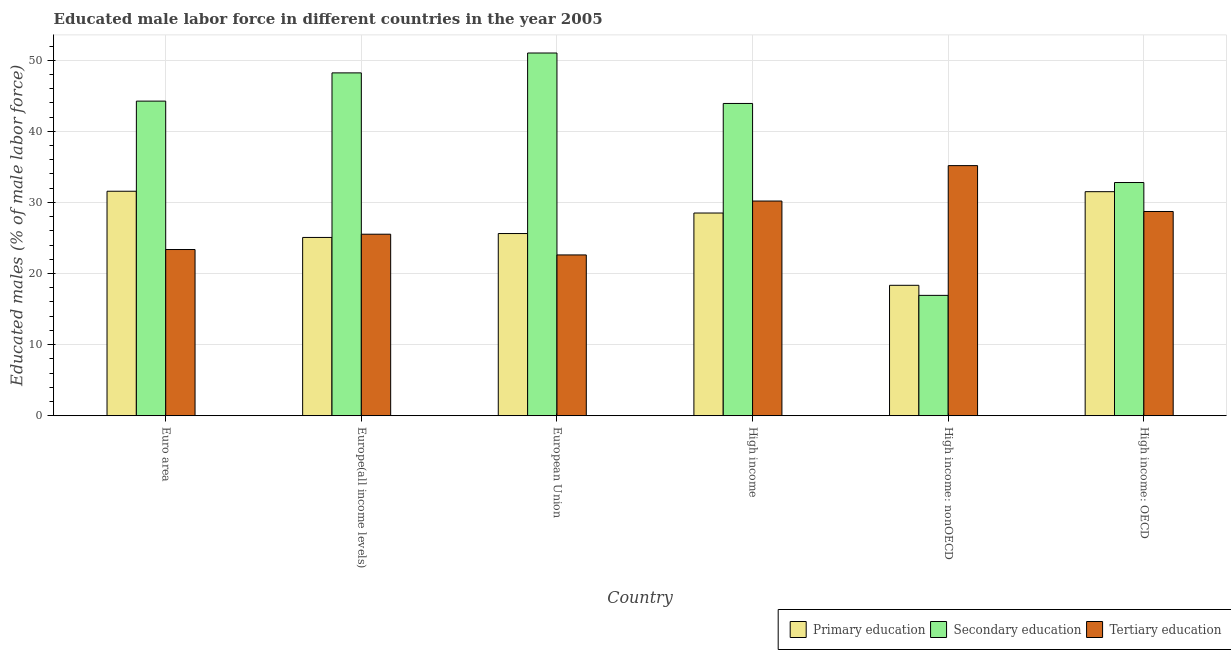How many groups of bars are there?
Your answer should be compact. 6. What is the percentage of male labor force who received primary education in High income: nonOECD?
Provide a short and direct response. 18.34. Across all countries, what is the maximum percentage of male labor force who received primary education?
Provide a succinct answer. 31.57. Across all countries, what is the minimum percentage of male labor force who received tertiary education?
Offer a very short reply. 22.62. In which country was the percentage of male labor force who received secondary education maximum?
Ensure brevity in your answer.  European Union. In which country was the percentage of male labor force who received secondary education minimum?
Your answer should be compact. High income: nonOECD. What is the total percentage of male labor force who received tertiary education in the graph?
Provide a short and direct response. 165.62. What is the difference between the percentage of male labor force who received primary education in Euro area and that in High income: nonOECD?
Keep it short and to the point. 13.23. What is the difference between the percentage of male labor force who received tertiary education in Euro area and the percentage of male labor force who received secondary education in High income: nonOECD?
Offer a very short reply. 6.45. What is the average percentage of male labor force who received tertiary education per country?
Provide a short and direct response. 27.6. What is the difference between the percentage of male labor force who received tertiary education and percentage of male labor force who received primary education in European Union?
Provide a succinct answer. -3.01. In how many countries, is the percentage of male labor force who received tertiary education greater than 24 %?
Your answer should be compact. 4. What is the ratio of the percentage of male labor force who received secondary education in European Union to that in High income: OECD?
Your answer should be compact. 1.56. Is the percentage of male labor force who received secondary education in Euro area less than that in High income: OECD?
Your answer should be compact. No. What is the difference between the highest and the second highest percentage of male labor force who received primary education?
Offer a very short reply. 0.06. What is the difference between the highest and the lowest percentage of male labor force who received secondary education?
Make the answer very short. 34.09. Is the sum of the percentage of male labor force who received secondary education in European Union and High income greater than the maximum percentage of male labor force who received tertiary education across all countries?
Your answer should be compact. Yes. What does the 1st bar from the left in Euro area represents?
Your answer should be compact. Primary education. What does the 1st bar from the right in High income represents?
Your response must be concise. Tertiary education. How many bars are there?
Provide a succinct answer. 18. Are all the bars in the graph horizontal?
Your response must be concise. No. How many countries are there in the graph?
Give a very brief answer. 6. Are the values on the major ticks of Y-axis written in scientific E-notation?
Ensure brevity in your answer.  No. Does the graph contain grids?
Your answer should be very brief. Yes. Where does the legend appear in the graph?
Offer a very short reply. Bottom right. How many legend labels are there?
Provide a succinct answer. 3. What is the title of the graph?
Give a very brief answer. Educated male labor force in different countries in the year 2005. Does "Refusal of sex" appear as one of the legend labels in the graph?
Your answer should be compact. No. What is the label or title of the X-axis?
Ensure brevity in your answer.  Country. What is the label or title of the Y-axis?
Give a very brief answer. Educated males (% of male labor force). What is the Educated males (% of male labor force) of Primary education in Euro area?
Your answer should be very brief. 31.57. What is the Educated males (% of male labor force) of Secondary education in Euro area?
Provide a short and direct response. 44.25. What is the Educated males (% of male labor force) of Tertiary education in Euro area?
Your answer should be very brief. 23.38. What is the Educated males (% of male labor force) of Primary education in Europe(all income levels)?
Give a very brief answer. 25.07. What is the Educated males (% of male labor force) in Secondary education in Europe(all income levels)?
Offer a terse response. 48.22. What is the Educated males (% of male labor force) of Tertiary education in Europe(all income levels)?
Your answer should be very brief. 25.53. What is the Educated males (% of male labor force) in Primary education in European Union?
Your response must be concise. 25.62. What is the Educated males (% of male labor force) in Secondary education in European Union?
Your answer should be compact. 51.01. What is the Educated males (% of male labor force) in Tertiary education in European Union?
Make the answer very short. 22.62. What is the Educated males (% of male labor force) in Primary education in High income?
Offer a very short reply. 28.51. What is the Educated males (% of male labor force) in Secondary education in High income?
Offer a terse response. 43.92. What is the Educated males (% of male labor force) of Tertiary education in High income?
Ensure brevity in your answer.  30.2. What is the Educated males (% of male labor force) in Primary education in High income: nonOECD?
Ensure brevity in your answer.  18.34. What is the Educated males (% of male labor force) of Secondary education in High income: nonOECD?
Your answer should be very brief. 16.93. What is the Educated males (% of male labor force) of Tertiary education in High income: nonOECD?
Provide a short and direct response. 35.18. What is the Educated males (% of male labor force) in Primary education in High income: OECD?
Give a very brief answer. 31.51. What is the Educated males (% of male labor force) in Secondary education in High income: OECD?
Provide a short and direct response. 32.8. What is the Educated males (% of male labor force) of Tertiary education in High income: OECD?
Keep it short and to the point. 28.72. Across all countries, what is the maximum Educated males (% of male labor force) of Primary education?
Ensure brevity in your answer.  31.57. Across all countries, what is the maximum Educated males (% of male labor force) in Secondary education?
Ensure brevity in your answer.  51.01. Across all countries, what is the maximum Educated males (% of male labor force) of Tertiary education?
Offer a terse response. 35.18. Across all countries, what is the minimum Educated males (% of male labor force) in Primary education?
Your answer should be very brief. 18.34. Across all countries, what is the minimum Educated males (% of male labor force) in Secondary education?
Offer a terse response. 16.93. Across all countries, what is the minimum Educated males (% of male labor force) in Tertiary education?
Provide a short and direct response. 22.62. What is the total Educated males (% of male labor force) of Primary education in the graph?
Provide a short and direct response. 160.63. What is the total Educated males (% of male labor force) in Secondary education in the graph?
Provide a succinct answer. 237.13. What is the total Educated males (% of male labor force) of Tertiary education in the graph?
Offer a terse response. 165.62. What is the difference between the Educated males (% of male labor force) in Primary education in Euro area and that in Europe(all income levels)?
Provide a succinct answer. 6.5. What is the difference between the Educated males (% of male labor force) in Secondary education in Euro area and that in Europe(all income levels)?
Offer a terse response. -3.97. What is the difference between the Educated males (% of male labor force) in Tertiary education in Euro area and that in Europe(all income levels)?
Offer a terse response. -2.15. What is the difference between the Educated males (% of male labor force) of Primary education in Euro area and that in European Union?
Ensure brevity in your answer.  5.95. What is the difference between the Educated males (% of male labor force) of Secondary education in Euro area and that in European Union?
Offer a terse response. -6.77. What is the difference between the Educated males (% of male labor force) of Tertiary education in Euro area and that in European Union?
Ensure brevity in your answer.  0.76. What is the difference between the Educated males (% of male labor force) of Primary education in Euro area and that in High income?
Your answer should be compact. 3.06. What is the difference between the Educated males (% of male labor force) of Secondary education in Euro area and that in High income?
Your answer should be compact. 0.33. What is the difference between the Educated males (% of male labor force) of Tertiary education in Euro area and that in High income?
Your response must be concise. -6.82. What is the difference between the Educated males (% of male labor force) of Primary education in Euro area and that in High income: nonOECD?
Make the answer very short. 13.23. What is the difference between the Educated males (% of male labor force) in Secondary education in Euro area and that in High income: nonOECD?
Give a very brief answer. 27.32. What is the difference between the Educated males (% of male labor force) in Tertiary education in Euro area and that in High income: nonOECD?
Provide a succinct answer. -11.8. What is the difference between the Educated males (% of male labor force) in Primary education in Euro area and that in High income: OECD?
Your answer should be very brief. 0.06. What is the difference between the Educated males (% of male labor force) in Secondary education in Euro area and that in High income: OECD?
Your answer should be very brief. 11.45. What is the difference between the Educated males (% of male labor force) in Tertiary education in Euro area and that in High income: OECD?
Provide a short and direct response. -5.35. What is the difference between the Educated males (% of male labor force) in Primary education in Europe(all income levels) and that in European Union?
Give a very brief answer. -0.55. What is the difference between the Educated males (% of male labor force) of Secondary education in Europe(all income levels) and that in European Union?
Your answer should be very brief. -2.8. What is the difference between the Educated males (% of male labor force) in Tertiary education in Europe(all income levels) and that in European Union?
Your answer should be compact. 2.91. What is the difference between the Educated males (% of male labor force) of Primary education in Europe(all income levels) and that in High income?
Your answer should be very brief. -3.43. What is the difference between the Educated males (% of male labor force) in Secondary education in Europe(all income levels) and that in High income?
Offer a terse response. 4.3. What is the difference between the Educated males (% of male labor force) of Tertiary education in Europe(all income levels) and that in High income?
Give a very brief answer. -4.67. What is the difference between the Educated males (% of male labor force) in Primary education in Europe(all income levels) and that in High income: nonOECD?
Make the answer very short. 6.73. What is the difference between the Educated males (% of male labor force) of Secondary education in Europe(all income levels) and that in High income: nonOECD?
Provide a succinct answer. 31.29. What is the difference between the Educated males (% of male labor force) of Tertiary education in Europe(all income levels) and that in High income: nonOECD?
Ensure brevity in your answer.  -9.65. What is the difference between the Educated males (% of male labor force) in Primary education in Europe(all income levels) and that in High income: OECD?
Your response must be concise. -6.44. What is the difference between the Educated males (% of male labor force) of Secondary education in Europe(all income levels) and that in High income: OECD?
Ensure brevity in your answer.  15.42. What is the difference between the Educated males (% of male labor force) of Tertiary education in Europe(all income levels) and that in High income: OECD?
Offer a very short reply. -3.19. What is the difference between the Educated males (% of male labor force) of Primary education in European Union and that in High income?
Your answer should be compact. -2.89. What is the difference between the Educated males (% of male labor force) of Secondary education in European Union and that in High income?
Provide a short and direct response. 7.09. What is the difference between the Educated males (% of male labor force) in Tertiary education in European Union and that in High income?
Give a very brief answer. -7.58. What is the difference between the Educated males (% of male labor force) in Primary education in European Union and that in High income: nonOECD?
Provide a short and direct response. 7.28. What is the difference between the Educated males (% of male labor force) in Secondary education in European Union and that in High income: nonOECD?
Provide a succinct answer. 34.09. What is the difference between the Educated males (% of male labor force) of Tertiary education in European Union and that in High income: nonOECD?
Your answer should be very brief. -12.56. What is the difference between the Educated males (% of male labor force) of Primary education in European Union and that in High income: OECD?
Keep it short and to the point. -5.89. What is the difference between the Educated males (% of male labor force) in Secondary education in European Union and that in High income: OECD?
Your response must be concise. 18.21. What is the difference between the Educated males (% of male labor force) in Tertiary education in European Union and that in High income: OECD?
Keep it short and to the point. -6.11. What is the difference between the Educated males (% of male labor force) in Primary education in High income and that in High income: nonOECD?
Offer a terse response. 10.17. What is the difference between the Educated males (% of male labor force) of Secondary education in High income and that in High income: nonOECD?
Make the answer very short. 26.99. What is the difference between the Educated males (% of male labor force) in Tertiary education in High income and that in High income: nonOECD?
Offer a terse response. -4.98. What is the difference between the Educated males (% of male labor force) of Primary education in High income and that in High income: OECD?
Offer a terse response. -3. What is the difference between the Educated males (% of male labor force) in Secondary education in High income and that in High income: OECD?
Offer a very short reply. 11.12. What is the difference between the Educated males (% of male labor force) of Tertiary education in High income and that in High income: OECD?
Your response must be concise. 1.47. What is the difference between the Educated males (% of male labor force) of Primary education in High income: nonOECD and that in High income: OECD?
Offer a terse response. -13.17. What is the difference between the Educated males (% of male labor force) in Secondary education in High income: nonOECD and that in High income: OECD?
Provide a short and direct response. -15.87. What is the difference between the Educated males (% of male labor force) of Tertiary education in High income: nonOECD and that in High income: OECD?
Provide a short and direct response. 6.45. What is the difference between the Educated males (% of male labor force) of Primary education in Euro area and the Educated males (% of male labor force) of Secondary education in Europe(all income levels)?
Offer a terse response. -16.65. What is the difference between the Educated males (% of male labor force) in Primary education in Euro area and the Educated males (% of male labor force) in Tertiary education in Europe(all income levels)?
Give a very brief answer. 6.04. What is the difference between the Educated males (% of male labor force) of Secondary education in Euro area and the Educated males (% of male labor force) of Tertiary education in Europe(all income levels)?
Ensure brevity in your answer.  18.72. What is the difference between the Educated males (% of male labor force) in Primary education in Euro area and the Educated males (% of male labor force) in Secondary education in European Union?
Keep it short and to the point. -19.44. What is the difference between the Educated males (% of male labor force) of Primary education in Euro area and the Educated males (% of male labor force) of Tertiary education in European Union?
Your response must be concise. 8.96. What is the difference between the Educated males (% of male labor force) in Secondary education in Euro area and the Educated males (% of male labor force) in Tertiary education in European Union?
Give a very brief answer. 21.63. What is the difference between the Educated males (% of male labor force) of Primary education in Euro area and the Educated males (% of male labor force) of Secondary education in High income?
Ensure brevity in your answer.  -12.35. What is the difference between the Educated males (% of male labor force) of Primary education in Euro area and the Educated males (% of male labor force) of Tertiary education in High income?
Keep it short and to the point. 1.38. What is the difference between the Educated males (% of male labor force) of Secondary education in Euro area and the Educated males (% of male labor force) of Tertiary education in High income?
Offer a terse response. 14.05. What is the difference between the Educated males (% of male labor force) of Primary education in Euro area and the Educated males (% of male labor force) of Secondary education in High income: nonOECD?
Offer a very short reply. 14.64. What is the difference between the Educated males (% of male labor force) in Primary education in Euro area and the Educated males (% of male labor force) in Tertiary education in High income: nonOECD?
Your answer should be compact. -3.6. What is the difference between the Educated males (% of male labor force) of Secondary education in Euro area and the Educated males (% of male labor force) of Tertiary education in High income: nonOECD?
Give a very brief answer. 9.07. What is the difference between the Educated males (% of male labor force) in Primary education in Euro area and the Educated males (% of male labor force) in Secondary education in High income: OECD?
Offer a very short reply. -1.23. What is the difference between the Educated males (% of male labor force) of Primary education in Euro area and the Educated males (% of male labor force) of Tertiary education in High income: OECD?
Make the answer very short. 2.85. What is the difference between the Educated males (% of male labor force) in Secondary education in Euro area and the Educated males (% of male labor force) in Tertiary education in High income: OECD?
Provide a short and direct response. 15.52. What is the difference between the Educated males (% of male labor force) in Primary education in Europe(all income levels) and the Educated males (% of male labor force) in Secondary education in European Union?
Your answer should be very brief. -25.94. What is the difference between the Educated males (% of male labor force) of Primary education in Europe(all income levels) and the Educated males (% of male labor force) of Tertiary education in European Union?
Your answer should be compact. 2.46. What is the difference between the Educated males (% of male labor force) of Secondary education in Europe(all income levels) and the Educated males (% of male labor force) of Tertiary education in European Union?
Your answer should be very brief. 25.6. What is the difference between the Educated males (% of male labor force) in Primary education in Europe(all income levels) and the Educated males (% of male labor force) in Secondary education in High income?
Provide a short and direct response. -18.84. What is the difference between the Educated males (% of male labor force) of Primary education in Europe(all income levels) and the Educated males (% of male labor force) of Tertiary education in High income?
Offer a terse response. -5.12. What is the difference between the Educated males (% of male labor force) in Secondary education in Europe(all income levels) and the Educated males (% of male labor force) in Tertiary education in High income?
Your response must be concise. 18.02. What is the difference between the Educated males (% of male labor force) of Primary education in Europe(all income levels) and the Educated males (% of male labor force) of Secondary education in High income: nonOECD?
Provide a short and direct response. 8.15. What is the difference between the Educated males (% of male labor force) in Primary education in Europe(all income levels) and the Educated males (% of male labor force) in Tertiary education in High income: nonOECD?
Keep it short and to the point. -10.1. What is the difference between the Educated males (% of male labor force) of Secondary education in Europe(all income levels) and the Educated males (% of male labor force) of Tertiary education in High income: nonOECD?
Your answer should be compact. 13.04. What is the difference between the Educated males (% of male labor force) in Primary education in Europe(all income levels) and the Educated males (% of male labor force) in Secondary education in High income: OECD?
Your answer should be very brief. -7.73. What is the difference between the Educated males (% of male labor force) of Primary education in Europe(all income levels) and the Educated males (% of male labor force) of Tertiary education in High income: OECD?
Make the answer very short. -3.65. What is the difference between the Educated males (% of male labor force) of Secondary education in Europe(all income levels) and the Educated males (% of male labor force) of Tertiary education in High income: OECD?
Give a very brief answer. 19.49. What is the difference between the Educated males (% of male labor force) in Primary education in European Union and the Educated males (% of male labor force) in Secondary education in High income?
Ensure brevity in your answer.  -18.3. What is the difference between the Educated males (% of male labor force) in Primary education in European Union and the Educated males (% of male labor force) in Tertiary education in High income?
Give a very brief answer. -4.57. What is the difference between the Educated males (% of male labor force) of Secondary education in European Union and the Educated males (% of male labor force) of Tertiary education in High income?
Give a very brief answer. 20.82. What is the difference between the Educated males (% of male labor force) of Primary education in European Union and the Educated males (% of male labor force) of Secondary education in High income: nonOECD?
Your response must be concise. 8.69. What is the difference between the Educated males (% of male labor force) of Primary education in European Union and the Educated males (% of male labor force) of Tertiary education in High income: nonOECD?
Offer a terse response. -9.55. What is the difference between the Educated males (% of male labor force) of Secondary education in European Union and the Educated males (% of male labor force) of Tertiary education in High income: nonOECD?
Make the answer very short. 15.84. What is the difference between the Educated males (% of male labor force) in Primary education in European Union and the Educated males (% of male labor force) in Secondary education in High income: OECD?
Your answer should be very brief. -7.18. What is the difference between the Educated males (% of male labor force) of Primary education in European Union and the Educated males (% of male labor force) of Tertiary education in High income: OECD?
Offer a terse response. -3.1. What is the difference between the Educated males (% of male labor force) of Secondary education in European Union and the Educated males (% of male labor force) of Tertiary education in High income: OECD?
Provide a succinct answer. 22.29. What is the difference between the Educated males (% of male labor force) of Primary education in High income and the Educated males (% of male labor force) of Secondary education in High income: nonOECD?
Provide a succinct answer. 11.58. What is the difference between the Educated males (% of male labor force) of Primary education in High income and the Educated males (% of male labor force) of Tertiary education in High income: nonOECD?
Offer a very short reply. -6.67. What is the difference between the Educated males (% of male labor force) of Secondary education in High income and the Educated males (% of male labor force) of Tertiary education in High income: nonOECD?
Provide a short and direct response. 8.74. What is the difference between the Educated males (% of male labor force) in Primary education in High income and the Educated males (% of male labor force) in Secondary education in High income: OECD?
Keep it short and to the point. -4.29. What is the difference between the Educated males (% of male labor force) in Primary education in High income and the Educated males (% of male labor force) in Tertiary education in High income: OECD?
Provide a short and direct response. -0.22. What is the difference between the Educated males (% of male labor force) of Secondary education in High income and the Educated males (% of male labor force) of Tertiary education in High income: OECD?
Your answer should be compact. 15.2. What is the difference between the Educated males (% of male labor force) of Primary education in High income: nonOECD and the Educated males (% of male labor force) of Secondary education in High income: OECD?
Ensure brevity in your answer.  -14.46. What is the difference between the Educated males (% of male labor force) of Primary education in High income: nonOECD and the Educated males (% of male labor force) of Tertiary education in High income: OECD?
Make the answer very short. -10.38. What is the difference between the Educated males (% of male labor force) of Secondary education in High income: nonOECD and the Educated males (% of male labor force) of Tertiary education in High income: OECD?
Offer a terse response. -11.8. What is the average Educated males (% of male labor force) in Primary education per country?
Your answer should be very brief. 26.77. What is the average Educated males (% of male labor force) in Secondary education per country?
Keep it short and to the point. 39.52. What is the average Educated males (% of male labor force) in Tertiary education per country?
Ensure brevity in your answer.  27.6. What is the difference between the Educated males (% of male labor force) in Primary education and Educated males (% of male labor force) in Secondary education in Euro area?
Offer a terse response. -12.68. What is the difference between the Educated males (% of male labor force) in Primary education and Educated males (% of male labor force) in Tertiary education in Euro area?
Offer a very short reply. 8.2. What is the difference between the Educated males (% of male labor force) in Secondary education and Educated males (% of male labor force) in Tertiary education in Euro area?
Your response must be concise. 20.87. What is the difference between the Educated males (% of male labor force) of Primary education and Educated males (% of male labor force) of Secondary education in Europe(all income levels)?
Provide a succinct answer. -23.14. What is the difference between the Educated males (% of male labor force) of Primary education and Educated males (% of male labor force) of Tertiary education in Europe(all income levels)?
Keep it short and to the point. -0.45. What is the difference between the Educated males (% of male labor force) of Secondary education and Educated males (% of male labor force) of Tertiary education in Europe(all income levels)?
Ensure brevity in your answer.  22.69. What is the difference between the Educated males (% of male labor force) in Primary education and Educated males (% of male labor force) in Secondary education in European Union?
Your response must be concise. -25.39. What is the difference between the Educated males (% of male labor force) of Primary education and Educated males (% of male labor force) of Tertiary education in European Union?
Keep it short and to the point. 3.01. What is the difference between the Educated males (% of male labor force) of Secondary education and Educated males (% of male labor force) of Tertiary education in European Union?
Your response must be concise. 28.4. What is the difference between the Educated males (% of male labor force) in Primary education and Educated males (% of male labor force) in Secondary education in High income?
Provide a succinct answer. -15.41. What is the difference between the Educated males (% of male labor force) in Primary education and Educated males (% of male labor force) in Tertiary education in High income?
Keep it short and to the point. -1.69. What is the difference between the Educated males (% of male labor force) of Secondary education and Educated males (% of male labor force) of Tertiary education in High income?
Your answer should be very brief. 13.72. What is the difference between the Educated males (% of male labor force) in Primary education and Educated males (% of male labor force) in Secondary education in High income: nonOECD?
Keep it short and to the point. 1.41. What is the difference between the Educated males (% of male labor force) in Primary education and Educated males (% of male labor force) in Tertiary education in High income: nonOECD?
Your answer should be very brief. -16.83. What is the difference between the Educated males (% of male labor force) in Secondary education and Educated males (% of male labor force) in Tertiary education in High income: nonOECD?
Offer a terse response. -18.25. What is the difference between the Educated males (% of male labor force) in Primary education and Educated males (% of male labor force) in Secondary education in High income: OECD?
Your response must be concise. -1.29. What is the difference between the Educated males (% of male labor force) in Primary education and Educated males (% of male labor force) in Tertiary education in High income: OECD?
Your answer should be very brief. 2.79. What is the difference between the Educated males (% of male labor force) of Secondary education and Educated males (% of male labor force) of Tertiary education in High income: OECD?
Provide a succinct answer. 4.08. What is the ratio of the Educated males (% of male labor force) in Primary education in Euro area to that in Europe(all income levels)?
Offer a terse response. 1.26. What is the ratio of the Educated males (% of male labor force) in Secondary education in Euro area to that in Europe(all income levels)?
Keep it short and to the point. 0.92. What is the ratio of the Educated males (% of male labor force) in Tertiary education in Euro area to that in Europe(all income levels)?
Give a very brief answer. 0.92. What is the ratio of the Educated males (% of male labor force) in Primary education in Euro area to that in European Union?
Offer a very short reply. 1.23. What is the ratio of the Educated males (% of male labor force) of Secondary education in Euro area to that in European Union?
Ensure brevity in your answer.  0.87. What is the ratio of the Educated males (% of male labor force) of Tertiary education in Euro area to that in European Union?
Your answer should be very brief. 1.03. What is the ratio of the Educated males (% of male labor force) of Primary education in Euro area to that in High income?
Your answer should be very brief. 1.11. What is the ratio of the Educated males (% of male labor force) in Secondary education in Euro area to that in High income?
Your response must be concise. 1.01. What is the ratio of the Educated males (% of male labor force) in Tertiary education in Euro area to that in High income?
Provide a short and direct response. 0.77. What is the ratio of the Educated males (% of male labor force) of Primary education in Euro area to that in High income: nonOECD?
Offer a terse response. 1.72. What is the ratio of the Educated males (% of male labor force) in Secondary education in Euro area to that in High income: nonOECD?
Provide a succinct answer. 2.61. What is the ratio of the Educated males (% of male labor force) in Tertiary education in Euro area to that in High income: nonOECD?
Your response must be concise. 0.66. What is the ratio of the Educated males (% of male labor force) of Secondary education in Euro area to that in High income: OECD?
Offer a very short reply. 1.35. What is the ratio of the Educated males (% of male labor force) in Tertiary education in Euro area to that in High income: OECD?
Offer a terse response. 0.81. What is the ratio of the Educated males (% of male labor force) of Primary education in Europe(all income levels) to that in European Union?
Your response must be concise. 0.98. What is the ratio of the Educated males (% of male labor force) in Secondary education in Europe(all income levels) to that in European Union?
Ensure brevity in your answer.  0.95. What is the ratio of the Educated males (% of male labor force) in Tertiary education in Europe(all income levels) to that in European Union?
Keep it short and to the point. 1.13. What is the ratio of the Educated males (% of male labor force) of Primary education in Europe(all income levels) to that in High income?
Your answer should be very brief. 0.88. What is the ratio of the Educated males (% of male labor force) of Secondary education in Europe(all income levels) to that in High income?
Ensure brevity in your answer.  1.1. What is the ratio of the Educated males (% of male labor force) of Tertiary education in Europe(all income levels) to that in High income?
Give a very brief answer. 0.85. What is the ratio of the Educated males (% of male labor force) of Primary education in Europe(all income levels) to that in High income: nonOECD?
Your answer should be compact. 1.37. What is the ratio of the Educated males (% of male labor force) of Secondary education in Europe(all income levels) to that in High income: nonOECD?
Your answer should be very brief. 2.85. What is the ratio of the Educated males (% of male labor force) in Tertiary education in Europe(all income levels) to that in High income: nonOECD?
Your response must be concise. 0.73. What is the ratio of the Educated males (% of male labor force) in Primary education in Europe(all income levels) to that in High income: OECD?
Offer a terse response. 0.8. What is the ratio of the Educated males (% of male labor force) in Secondary education in Europe(all income levels) to that in High income: OECD?
Provide a short and direct response. 1.47. What is the ratio of the Educated males (% of male labor force) in Tertiary education in Europe(all income levels) to that in High income: OECD?
Give a very brief answer. 0.89. What is the ratio of the Educated males (% of male labor force) of Primary education in European Union to that in High income?
Ensure brevity in your answer.  0.9. What is the ratio of the Educated males (% of male labor force) of Secondary education in European Union to that in High income?
Give a very brief answer. 1.16. What is the ratio of the Educated males (% of male labor force) in Tertiary education in European Union to that in High income?
Your answer should be very brief. 0.75. What is the ratio of the Educated males (% of male labor force) of Primary education in European Union to that in High income: nonOECD?
Provide a short and direct response. 1.4. What is the ratio of the Educated males (% of male labor force) of Secondary education in European Union to that in High income: nonOECD?
Ensure brevity in your answer.  3.01. What is the ratio of the Educated males (% of male labor force) of Tertiary education in European Union to that in High income: nonOECD?
Provide a short and direct response. 0.64. What is the ratio of the Educated males (% of male labor force) in Primary education in European Union to that in High income: OECD?
Provide a succinct answer. 0.81. What is the ratio of the Educated males (% of male labor force) in Secondary education in European Union to that in High income: OECD?
Your answer should be very brief. 1.56. What is the ratio of the Educated males (% of male labor force) in Tertiary education in European Union to that in High income: OECD?
Offer a very short reply. 0.79. What is the ratio of the Educated males (% of male labor force) in Primary education in High income to that in High income: nonOECD?
Ensure brevity in your answer.  1.55. What is the ratio of the Educated males (% of male labor force) in Secondary education in High income to that in High income: nonOECD?
Your answer should be very brief. 2.59. What is the ratio of the Educated males (% of male labor force) in Tertiary education in High income to that in High income: nonOECD?
Your response must be concise. 0.86. What is the ratio of the Educated males (% of male labor force) of Primary education in High income to that in High income: OECD?
Provide a short and direct response. 0.9. What is the ratio of the Educated males (% of male labor force) of Secondary education in High income to that in High income: OECD?
Keep it short and to the point. 1.34. What is the ratio of the Educated males (% of male labor force) in Tertiary education in High income to that in High income: OECD?
Your answer should be compact. 1.05. What is the ratio of the Educated males (% of male labor force) of Primary education in High income: nonOECD to that in High income: OECD?
Your answer should be very brief. 0.58. What is the ratio of the Educated males (% of male labor force) in Secondary education in High income: nonOECD to that in High income: OECD?
Provide a short and direct response. 0.52. What is the ratio of the Educated males (% of male labor force) in Tertiary education in High income: nonOECD to that in High income: OECD?
Your answer should be very brief. 1.22. What is the difference between the highest and the second highest Educated males (% of male labor force) of Primary education?
Offer a very short reply. 0.06. What is the difference between the highest and the second highest Educated males (% of male labor force) in Secondary education?
Make the answer very short. 2.8. What is the difference between the highest and the second highest Educated males (% of male labor force) of Tertiary education?
Your answer should be very brief. 4.98. What is the difference between the highest and the lowest Educated males (% of male labor force) of Primary education?
Make the answer very short. 13.23. What is the difference between the highest and the lowest Educated males (% of male labor force) in Secondary education?
Provide a short and direct response. 34.09. What is the difference between the highest and the lowest Educated males (% of male labor force) of Tertiary education?
Offer a very short reply. 12.56. 